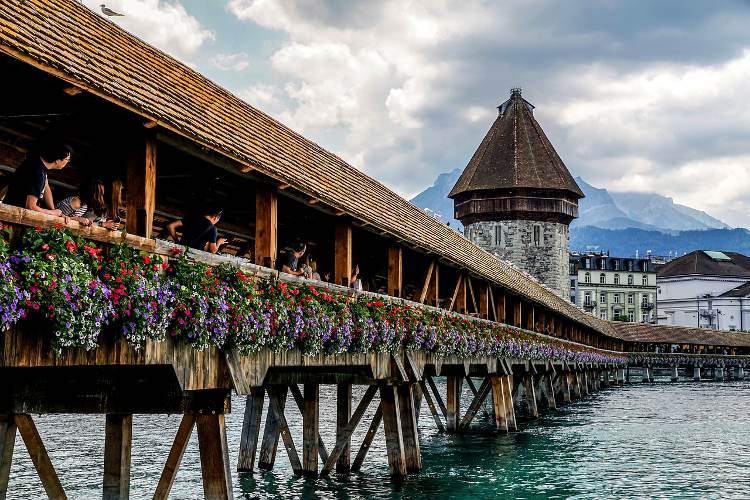What role do the flowers play in enhancing the bridge's appearance? The flowers along the Chapel Bridge play a significant role in enhancing its aesthetic appeal. Each year, the bridge is adorned with fresh blooms, which add a splash of color to the rustic wooden architecture. This not only enhances the visual appeal for tourists but also brings a vibrant, lively contrast to the historic, somber structure of the bridge, creating a picturesque scene that is often photographed and cherished by visitors. 